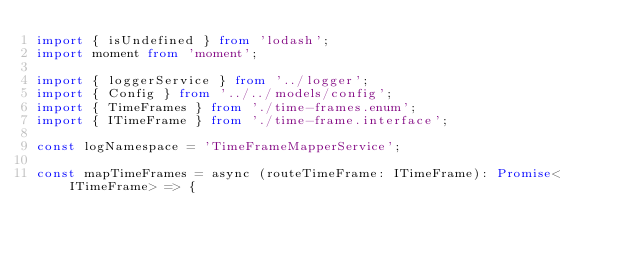<code> <loc_0><loc_0><loc_500><loc_500><_TypeScript_>import { isUndefined } from 'lodash';
import moment from 'moment';

import { loggerService } from '../logger';
import { Config } from '../../models/config';
import { TimeFrames } from './time-frames.enum';
import { ITimeFrame } from './time-frame.interface';

const logNamespace = 'TimeFrameMapperService';

const mapTimeFrames = async (routeTimeFrame: ITimeFrame): Promise<ITimeFrame> => {</code> 